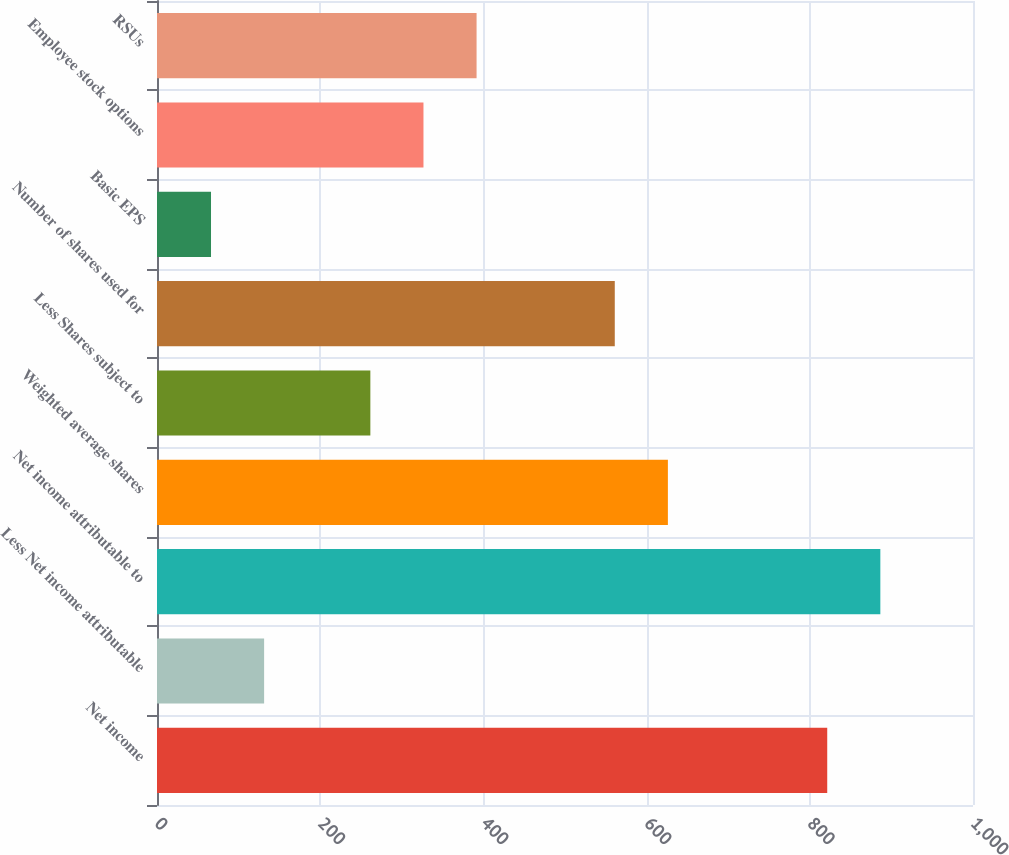Convert chart to OTSL. <chart><loc_0><loc_0><loc_500><loc_500><bar_chart><fcel>Net income<fcel>Less Net income attributable<fcel>Net income attributable to<fcel>Weighted average shares<fcel>Less Shares subject to<fcel>Number of shares used for<fcel>Basic EPS<fcel>Employee stock options<fcel>RSUs<nl><fcel>821.36<fcel>131.28<fcel>886.45<fcel>626.09<fcel>261.46<fcel>561<fcel>66.19<fcel>326.55<fcel>391.64<nl></chart> 